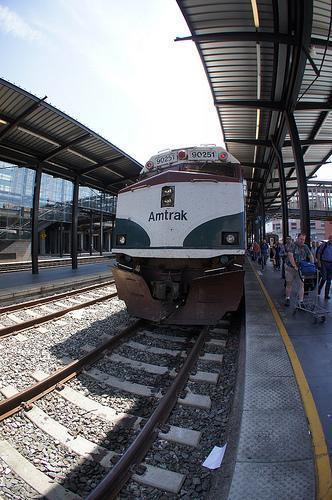How many trains are there?
Give a very brief answer. 1. 